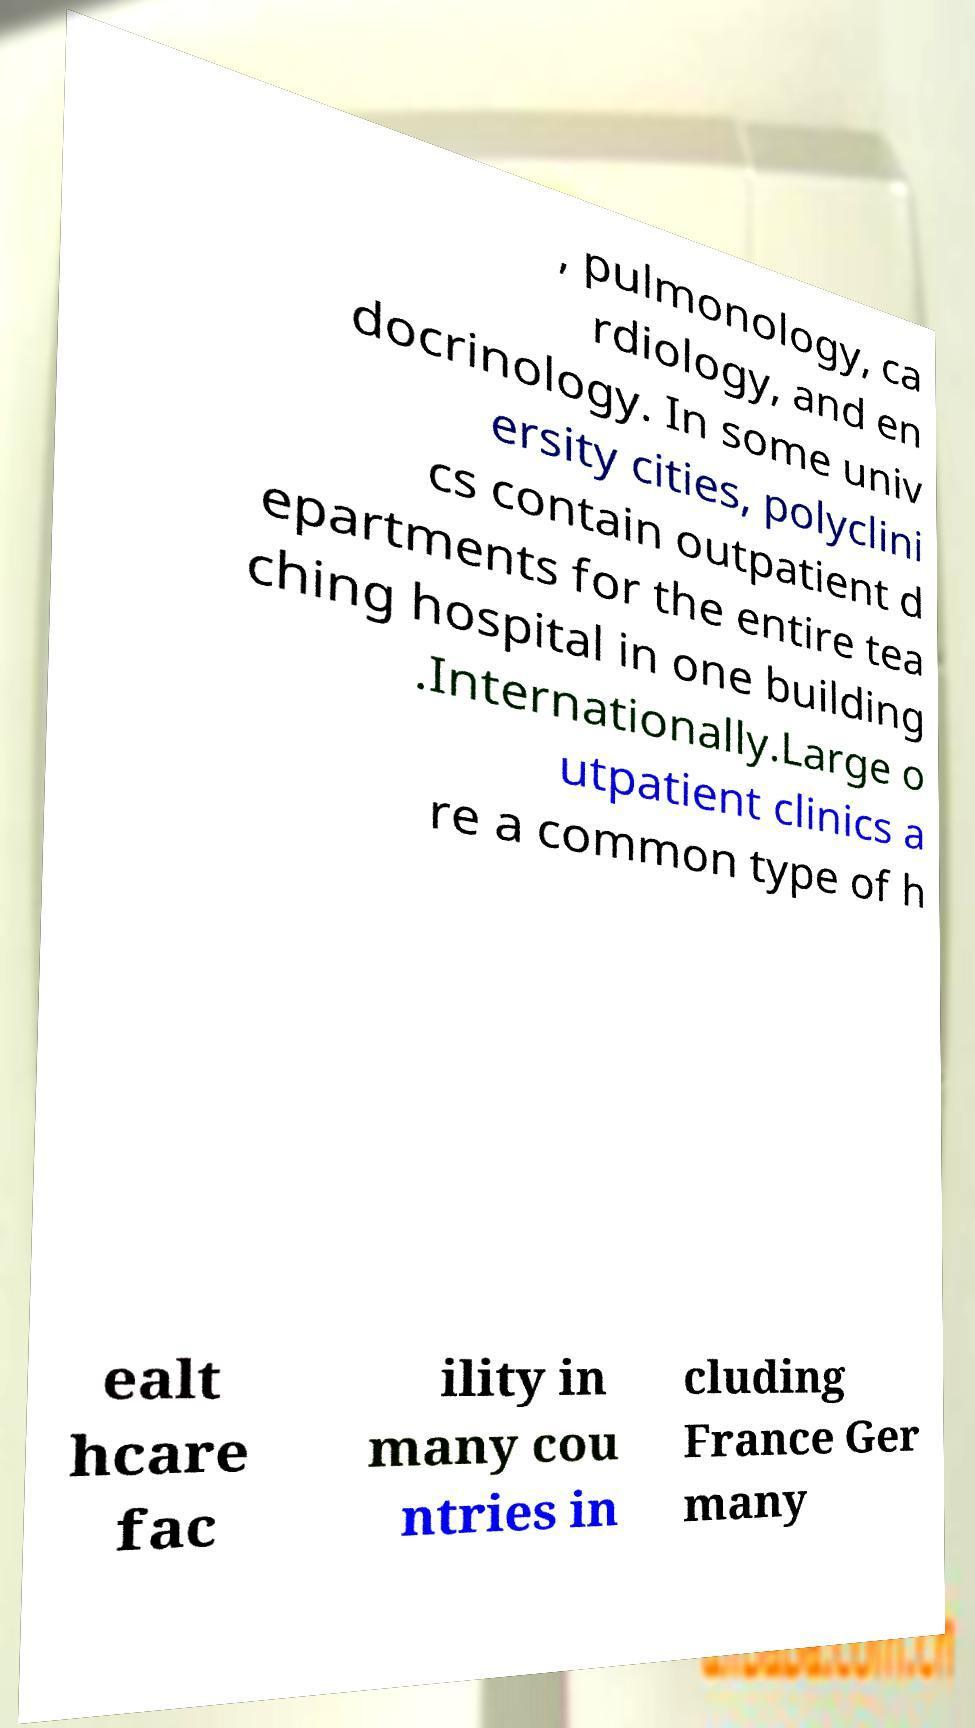Could you assist in decoding the text presented in this image and type it out clearly? , pulmonology, ca rdiology, and en docrinology. In some univ ersity cities, polyclini cs contain outpatient d epartments for the entire tea ching hospital in one building .Internationally.Large o utpatient clinics a re a common type of h ealt hcare fac ility in many cou ntries in cluding France Ger many 